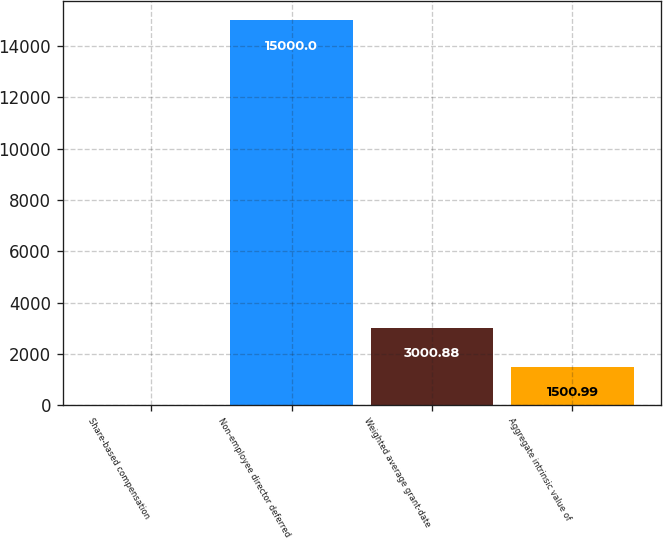Convert chart to OTSL. <chart><loc_0><loc_0><loc_500><loc_500><bar_chart><fcel>Share-based compensation<fcel>Non-employee director deferred<fcel>Weighted average grant-date<fcel>Aggregate intrinsic value of<nl><fcel>1.1<fcel>15000<fcel>3000.88<fcel>1500.99<nl></chart> 